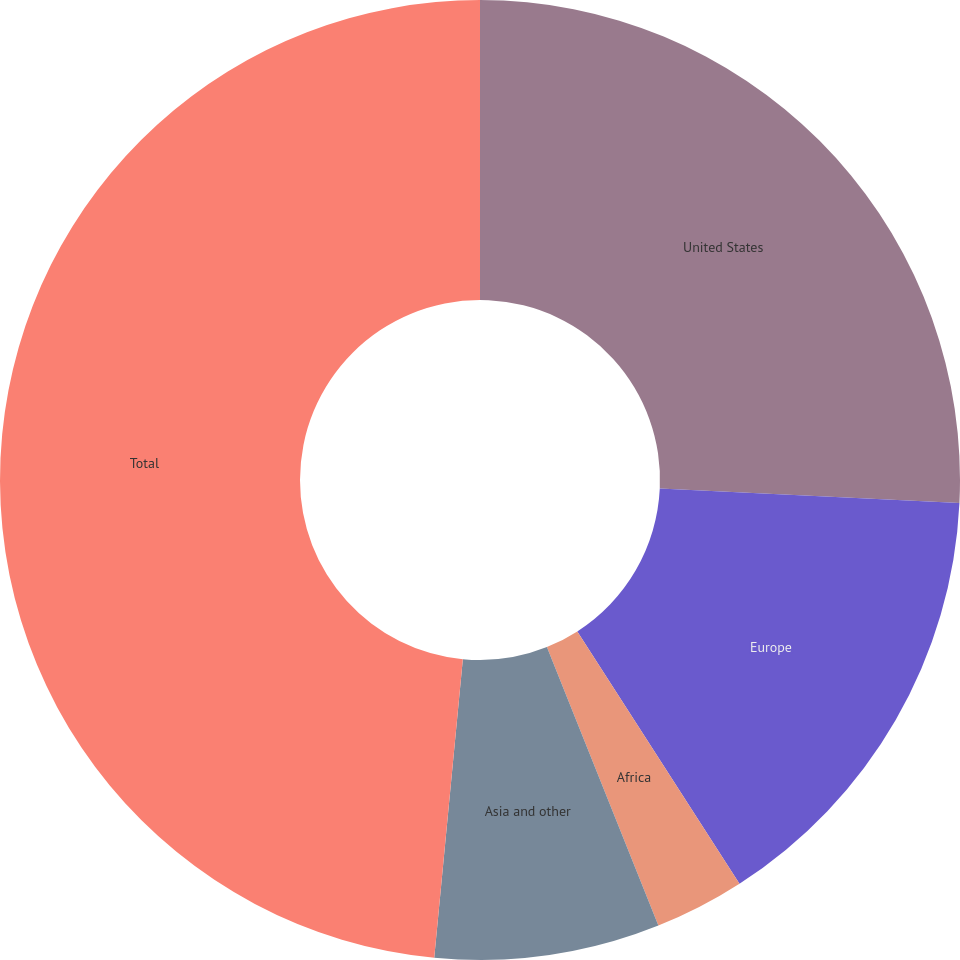Convert chart to OTSL. <chart><loc_0><loc_0><loc_500><loc_500><pie_chart><fcel>United States<fcel>Europe<fcel>Africa<fcel>Asia and other<fcel>Total<nl><fcel>25.76%<fcel>15.15%<fcel>3.03%<fcel>7.58%<fcel>48.48%<nl></chart> 